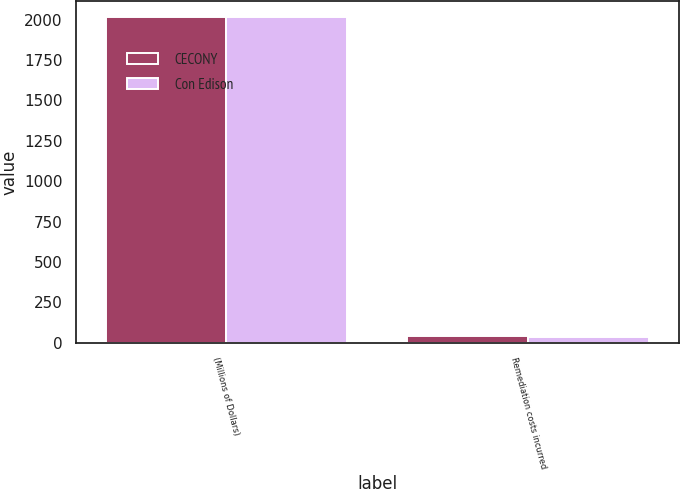<chart> <loc_0><loc_0><loc_500><loc_500><stacked_bar_chart><ecel><fcel>(Millions of Dollars)<fcel>Remediation costs incurred<nl><fcel>CECONY<fcel>2013<fcel>41<nl><fcel>Con Edison<fcel>2013<fcel>35<nl></chart> 